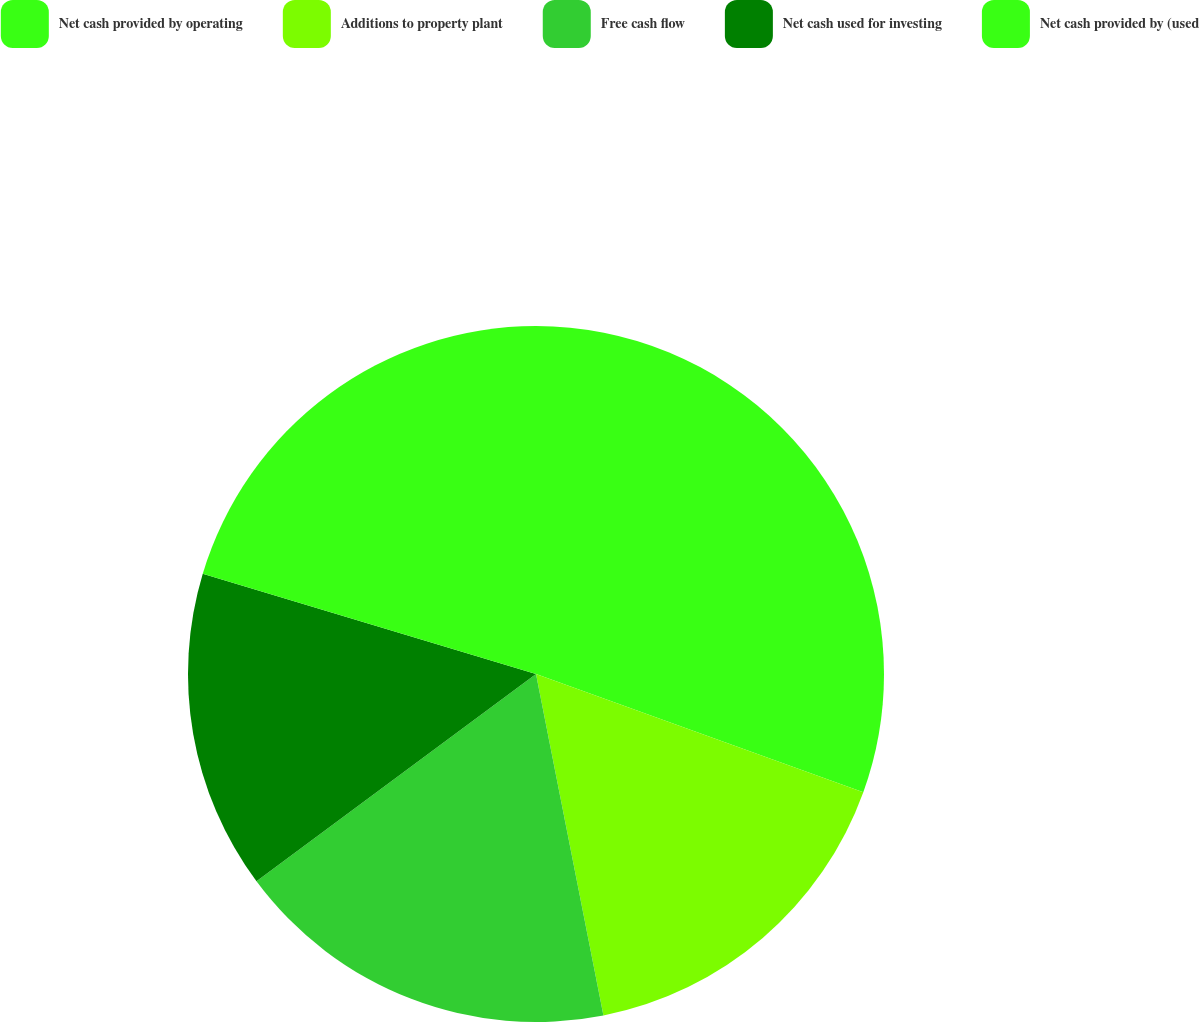Convert chart. <chart><loc_0><loc_0><loc_500><loc_500><pie_chart><fcel>Net cash provided by operating<fcel>Additions to property plant<fcel>Free cash flow<fcel>Net cash used for investing<fcel>Net cash provided by (used<nl><fcel>30.52%<fcel>16.38%<fcel>17.95%<fcel>14.81%<fcel>20.35%<nl></chart> 